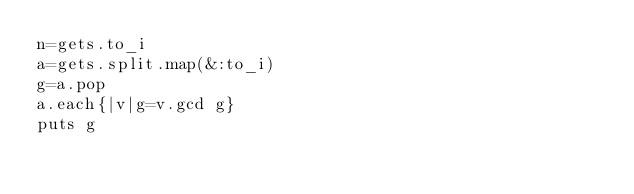<code> <loc_0><loc_0><loc_500><loc_500><_Ruby_>n=gets.to_i
a=gets.split.map(&:to_i)
g=a.pop
a.each{|v|g=v.gcd g}
puts g</code> 